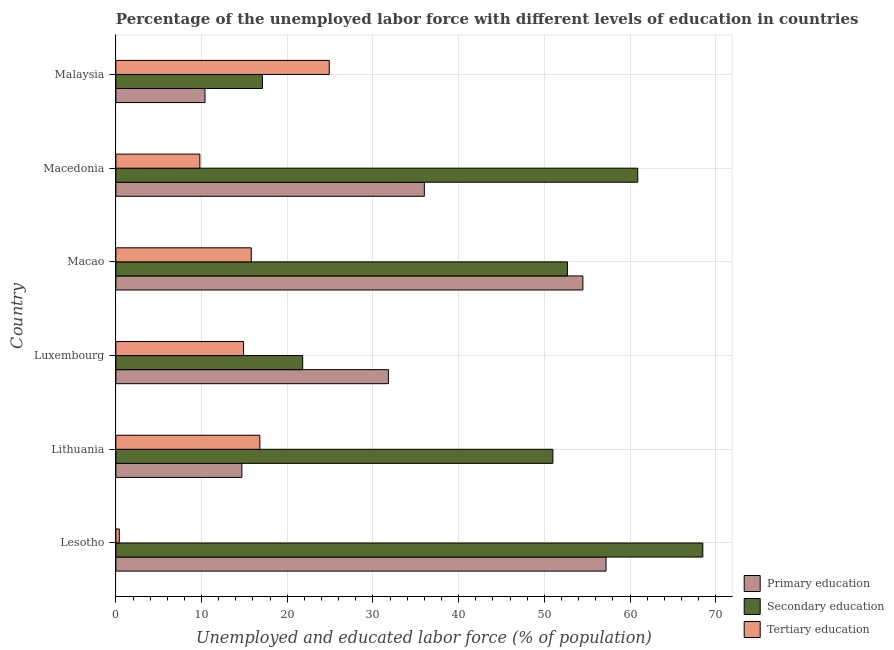How many groups of bars are there?
Your answer should be very brief. 6. Are the number of bars per tick equal to the number of legend labels?
Provide a short and direct response. Yes. What is the label of the 1st group of bars from the top?
Provide a succinct answer. Malaysia. In how many cases, is the number of bars for a given country not equal to the number of legend labels?
Your response must be concise. 0. What is the percentage of labor force who received primary education in Lithuania?
Offer a very short reply. 14.7. Across all countries, what is the maximum percentage of labor force who received primary education?
Give a very brief answer. 57.2. Across all countries, what is the minimum percentage of labor force who received secondary education?
Provide a succinct answer. 17.1. In which country was the percentage of labor force who received secondary education maximum?
Make the answer very short. Lesotho. In which country was the percentage of labor force who received tertiary education minimum?
Keep it short and to the point. Lesotho. What is the total percentage of labor force who received tertiary education in the graph?
Offer a terse response. 82.6. What is the difference between the percentage of labor force who received tertiary education in Macao and that in Macedonia?
Ensure brevity in your answer.  6. What is the difference between the percentage of labor force who received tertiary education in Malaysia and the percentage of labor force who received secondary education in Luxembourg?
Offer a terse response. 3.1. What is the average percentage of labor force who received tertiary education per country?
Your answer should be compact. 13.77. What is the difference between the percentage of labor force who received primary education and percentage of labor force who received tertiary education in Macao?
Make the answer very short. 38.7. In how many countries, is the percentage of labor force who received tertiary education greater than 16 %?
Ensure brevity in your answer.  2. What is the ratio of the percentage of labor force who received primary education in Lithuania to that in Macedonia?
Make the answer very short. 0.41. Is the percentage of labor force who received tertiary education in Lithuania less than that in Macao?
Your response must be concise. No. Is the difference between the percentage of labor force who received secondary education in Lesotho and Macao greater than the difference between the percentage of labor force who received primary education in Lesotho and Macao?
Offer a terse response. Yes. What is the difference between the highest and the second highest percentage of labor force who received primary education?
Ensure brevity in your answer.  2.7. What is the difference between the highest and the lowest percentage of labor force who received secondary education?
Offer a very short reply. 51.4. In how many countries, is the percentage of labor force who received secondary education greater than the average percentage of labor force who received secondary education taken over all countries?
Make the answer very short. 4. Is the sum of the percentage of labor force who received tertiary education in Lithuania and Luxembourg greater than the maximum percentage of labor force who received primary education across all countries?
Your response must be concise. No. What does the 2nd bar from the bottom in Lesotho represents?
Provide a succinct answer. Secondary education. Are the values on the major ticks of X-axis written in scientific E-notation?
Your answer should be very brief. No. Does the graph contain any zero values?
Provide a short and direct response. No. What is the title of the graph?
Provide a succinct answer. Percentage of the unemployed labor force with different levels of education in countries. What is the label or title of the X-axis?
Give a very brief answer. Unemployed and educated labor force (% of population). What is the Unemployed and educated labor force (% of population) of Primary education in Lesotho?
Make the answer very short. 57.2. What is the Unemployed and educated labor force (% of population) of Secondary education in Lesotho?
Provide a short and direct response. 68.5. What is the Unemployed and educated labor force (% of population) of Tertiary education in Lesotho?
Offer a very short reply. 0.4. What is the Unemployed and educated labor force (% of population) in Primary education in Lithuania?
Make the answer very short. 14.7. What is the Unemployed and educated labor force (% of population) of Tertiary education in Lithuania?
Keep it short and to the point. 16.8. What is the Unemployed and educated labor force (% of population) in Primary education in Luxembourg?
Offer a terse response. 31.8. What is the Unemployed and educated labor force (% of population) of Secondary education in Luxembourg?
Your response must be concise. 21.8. What is the Unemployed and educated labor force (% of population) in Tertiary education in Luxembourg?
Offer a very short reply. 14.9. What is the Unemployed and educated labor force (% of population) of Primary education in Macao?
Keep it short and to the point. 54.5. What is the Unemployed and educated labor force (% of population) of Secondary education in Macao?
Ensure brevity in your answer.  52.7. What is the Unemployed and educated labor force (% of population) of Tertiary education in Macao?
Offer a very short reply. 15.8. What is the Unemployed and educated labor force (% of population) of Primary education in Macedonia?
Offer a very short reply. 36. What is the Unemployed and educated labor force (% of population) in Secondary education in Macedonia?
Your answer should be very brief. 60.9. What is the Unemployed and educated labor force (% of population) in Tertiary education in Macedonia?
Ensure brevity in your answer.  9.8. What is the Unemployed and educated labor force (% of population) of Primary education in Malaysia?
Your response must be concise. 10.4. What is the Unemployed and educated labor force (% of population) in Secondary education in Malaysia?
Offer a very short reply. 17.1. What is the Unemployed and educated labor force (% of population) in Tertiary education in Malaysia?
Offer a very short reply. 24.9. Across all countries, what is the maximum Unemployed and educated labor force (% of population) in Primary education?
Offer a very short reply. 57.2. Across all countries, what is the maximum Unemployed and educated labor force (% of population) of Secondary education?
Your response must be concise. 68.5. Across all countries, what is the maximum Unemployed and educated labor force (% of population) in Tertiary education?
Keep it short and to the point. 24.9. Across all countries, what is the minimum Unemployed and educated labor force (% of population) of Primary education?
Provide a succinct answer. 10.4. Across all countries, what is the minimum Unemployed and educated labor force (% of population) in Secondary education?
Keep it short and to the point. 17.1. Across all countries, what is the minimum Unemployed and educated labor force (% of population) in Tertiary education?
Make the answer very short. 0.4. What is the total Unemployed and educated labor force (% of population) of Primary education in the graph?
Make the answer very short. 204.6. What is the total Unemployed and educated labor force (% of population) of Secondary education in the graph?
Provide a short and direct response. 272. What is the total Unemployed and educated labor force (% of population) of Tertiary education in the graph?
Your response must be concise. 82.6. What is the difference between the Unemployed and educated labor force (% of population) in Primary education in Lesotho and that in Lithuania?
Your response must be concise. 42.5. What is the difference between the Unemployed and educated labor force (% of population) in Tertiary education in Lesotho and that in Lithuania?
Keep it short and to the point. -16.4. What is the difference between the Unemployed and educated labor force (% of population) in Primary education in Lesotho and that in Luxembourg?
Give a very brief answer. 25.4. What is the difference between the Unemployed and educated labor force (% of population) of Secondary education in Lesotho and that in Luxembourg?
Provide a succinct answer. 46.7. What is the difference between the Unemployed and educated labor force (% of population) of Tertiary education in Lesotho and that in Luxembourg?
Give a very brief answer. -14.5. What is the difference between the Unemployed and educated labor force (% of population) in Primary education in Lesotho and that in Macao?
Keep it short and to the point. 2.7. What is the difference between the Unemployed and educated labor force (% of population) in Tertiary education in Lesotho and that in Macao?
Make the answer very short. -15.4. What is the difference between the Unemployed and educated labor force (% of population) in Primary education in Lesotho and that in Macedonia?
Offer a terse response. 21.2. What is the difference between the Unemployed and educated labor force (% of population) of Secondary education in Lesotho and that in Macedonia?
Ensure brevity in your answer.  7.6. What is the difference between the Unemployed and educated labor force (% of population) of Primary education in Lesotho and that in Malaysia?
Ensure brevity in your answer.  46.8. What is the difference between the Unemployed and educated labor force (% of population) of Secondary education in Lesotho and that in Malaysia?
Keep it short and to the point. 51.4. What is the difference between the Unemployed and educated labor force (% of population) of Tertiary education in Lesotho and that in Malaysia?
Make the answer very short. -24.5. What is the difference between the Unemployed and educated labor force (% of population) of Primary education in Lithuania and that in Luxembourg?
Ensure brevity in your answer.  -17.1. What is the difference between the Unemployed and educated labor force (% of population) in Secondary education in Lithuania and that in Luxembourg?
Provide a succinct answer. 29.2. What is the difference between the Unemployed and educated labor force (% of population) in Tertiary education in Lithuania and that in Luxembourg?
Your response must be concise. 1.9. What is the difference between the Unemployed and educated labor force (% of population) in Primary education in Lithuania and that in Macao?
Make the answer very short. -39.8. What is the difference between the Unemployed and educated labor force (% of population) of Primary education in Lithuania and that in Macedonia?
Offer a very short reply. -21.3. What is the difference between the Unemployed and educated labor force (% of population) in Secondary education in Lithuania and that in Macedonia?
Make the answer very short. -9.9. What is the difference between the Unemployed and educated labor force (% of population) of Tertiary education in Lithuania and that in Macedonia?
Provide a short and direct response. 7. What is the difference between the Unemployed and educated labor force (% of population) in Secondary education in Lithuania and that in Malaysia?
Provide a short and direct response. 33.9. What is the difference between the Unemployed and educated labor force (% of population) of Tertiary education in Lithuania and that in Malaysia?
Provide a short and direct response. -8.1. What is the difference between the Unemployed and educated labor force (% of population) of Primary education in Luxembourg and that in Macao?
Provide a succinct answer. -22.7. What is the difference between the Unemployed and educated labor force (% of population) of Secondary education in Luxembourg and that in Macao?
Give a very brief answer. -30.9. What is the difference between the Unemployed and educated labor force (% of population) in Primary education in Luxembourg and that in Macedonia?
Ensure brevity in your answer.  -4.2. What is the difference between the Unemployed and educated labor force (% of population) of Secondary education in Luxembourg and that in Macedonia?
Your response must be concise. -39.1. What is the difference between the Unemployed and educated labor force (% of population) in Tertiary education in Luxembourg and that in Macedonia?
Provide a succinct answer. 5.1. What is the difference between the Unemployed and educated labor force (% of population) of Primary education in Luxembourg and that in Malaysia?
Your answer should be compact. 21.4. What is the difference between the Unemployed and educated labor force (% of population) in Primary education in Macao and that in Malaysia?
Offer a terse response. 44.1. What is the difference between the Unemployed and educated labor force (% of population) of Secondary education in Macao and that in Malaysia?
Offer a terse response. 35.6. What is the difference between the Unemployed and educated labor force (% of population) of Tertiary education in Macao and that in Malaysia?
Your response must be concise. -9.1. What is the difference between the Unemployed and educated labor force (% of population) of Primary education in Macedonia and that in Malaysia?
Provide a short and direct response. 25.6. What is the difference between the Unemployed and educated labor force (% of population) in Secondary education in Macedonia and that in Malaysia?
Ensure brevity in your answer.  43.8. What is the difference between the Unemployed and educated labor force (% of population) of Tertiary education in Macedonia and that in Malaysia?
Make the answer very short. -15.1. What is the difference between the Unemployed and educated labor force (% of population) in Primary education in Lesotho and the Unemployed and educated labor force (% of population) in Tertiary education in Lithuania?
Keep it short and to the point. 40.4. What is the difference between the Unemployed and educated labor force (% of population) in Secondary education in Lesotho and the Unemployed and educated labor force (% of population) in Tertiary education in Lithuania?
Keep it short and to the point. 51.7. What is the difference between the Unemployed and educated labor force (% of population) in Primary education in Lesotho and the Unemployed and educated labor force (% of population) in Secondary education in Luxembourg?
Your answer should be very brief. 35.4. What is the difference between the Unemployed and educated labor force (% of population) of Primary education in Lesotho and the Unemployed and educated labor force (% of population) of Tertiary education in Luxembourg?
Your response must be concise. 42.3. What is the difference between the Unemployed and educated labor force (% of population) in Secondary education in Lesotho and the Unemployed and educated labor force (% of population) in Tertiary education in Luxembourg?
Keep it short and to the point. 53.6. What is the difference between the Unemployed and educated labor force (% of population) of Primary education in Lesotho and the Unemployed and educated labor force (% of population) of Secondary education in Macao?
Make the answer very short. 4.5. What is the difference between the Unemployed and educated labor force (% of population) of Primary education in Lesotho and the Unemployed and educated labor force (% of population) of Tertiary education in Macao?
Your answer should be very brief. 41.4. What is the difference between the Unemployed and educated labor force (% of population) of Secondary education in Lesotho and the Unemployed and educated labor force (% of population) of Tertiary education in Macao?
Offer a very short reply. 52.7. What is the difference between the Unemployed and educated labor force (% of population) in Primary education in Lesotho and the Unemployed and educated labor force (% of population) in Tertiary education in Macedonia?
Your answer should be very brief. 47.4. What is the difference between the Unemployed and educated labor force (% of population) of Secondary education in Lesotho and the Unemployed and educated labor force (% of population) of Tertiary education in Macedonia?
Your answer should be compact. 58.7. What is the difference between the Unemployed and educated labor force (% of population) in Primary education in Lesotho and the Unemployed and educated labor force (% of population) in Secondary education in Malaysia?
Your answer should be compact. 40.1. What is the difference between the Unemployed and educated labor force (% of population) of Primary education in Lesotho and the Unemployed and educated labor force (% of population) of Tertiary education in Malaysia?
Provide a succinct answer. 32.3. What is the difference between the Unemployed and educated labor force (% of population) in Secondary education in Lesotho and the Unemployed and educated labor force (% of population) in Tertiary education in Malaysia?
Offer a terse response. 43.6. What is the difference between the Unemployed and educated labor force (% of population) of Primary education in Lithuania and the Unemployed and educated labor force (% of population) of Secondary education in Luxembourg?
Give a very brief answer. -7.1. What is the difference between the Unemployed and educated labor force (% of population) of Secondary education in Lithuania and the Unemployed and educated labor force (% of population) of Tertiary education in Luxembourg?
Give a very brief answer. 36.1. What is the difference between the Unemployed and educated labor force (% of population) in Primary education in Lithuania and the Unemployed and educated labor force (% of population) in Secondary education in Macao?
Provide a short and direct response. -38. What is the difference between the Unemployed and educated labor force (% of population) of Secondary education in Lithuania and the Unemployed and educated labor force (% of population) of Tertiary education in Macao?
Offer a very short reply. 35.2. What is the difference between the Unemployed and educated labor force (% of population) in Primary education in Lithuania and the Unemployed and educated labor force (% of population) in Secondary education in Macedonia?
Your answer should be compact. -46.2. What is the difference between the Unemployed and educated labor force (% of population) of Secondary education in Lithuania and the Unemployed and educated labor force (% of population) of Tertiary education in Macedonia?
Ensure brevity in your answer.  41.2. What is the difference between the Unemployed and educated labor force (% of population) of Primary education in Lithuania and the Unemployed and educated labor force (% of population) of Tertiary education in Malaysia?
Give a very brief answer. -10.2. What is the difference between the Unemployed and educated labor force (% of population) of Secondary education in Lithuania and the Unemployed and educated labor force (% of population) of Tertiary education in Malaysia?
Keep it short and to the point. 26.1. What is the difference between the Unemployed and educated labor force (% of population) of Primary education in Luxembourg and the Unemployed and educated labor force (% of population) of Secondary education in Macao?
Provide a succinct answer. -20.9. What is the difference between the Unemployed and educated labor force (% of population) of Primary education in Luxembourg and the Unemployed and educated labor force (% of population) of Tertiary education in Macao?
Provide a short and direct response. 16. What is the difference between the Unemployed and educated labor force (% of population) in Primary education in Luxembourg and the Unemployed and educated labor force (% of population) in Secondary education in Macedonia?
Your response must be concise. -29.1. What is the difference between the Unemployed and educated labor force (% of population) in Secondary education in Luxembourg and the Unemployed and educated labor force (% of population) in Tertiary education in Macedonia?
Ensure brevity in your answer.  12. What is the difference between the Unemployed and educated labor force (% of population) in Secondary education in Luxembourg and the Unemployed and educated labor force (% of population) in Tertiary education in Malaysia?
Your answer should be compact. -3.1. What is the difference between the Unemployed and educated labor force (% of population) in Primary education in Macao and the Unemployed and educated labor force (% of population) in Secondary education in Macedonia?
Offer a very short reply. -6.4. What is the difference between the Unemployed and educated labor force (% of population) in Primary education in Macao and the Unemployed and educated labor force (% of population) in Tertiary education in Macedonia?
Offer a very short reply. 44.7. What is the difference between the Unemployed and educated labor force (% of population) in Secondary education in Macao and the Unemployed and educated labor force (% of population) in Tertiary education in Macedonia?
Make the answer very short. 42.9. What is the difference between the Unemployed and educated labor force (% of population) of Primary education in Macao and the Unemployed and educated labor force (% of population) of Secondary education in Malaysia?
Your answer should be very brief. 37.4. What is the difference between the Unemployed and educated labor force (% of population) in Primary education in Macao and the Unemployed and educated labor force (% of population) in Tertiary education in Malaysia?
Keep it short and to the point. 29.6. What is the difference between the Unemployed and educated labor force (% of population) of Secondary education in Macao and the Unemployed and educated labor force (% of population) of Tertiary education in Malaysia?
Provide a short and direct response. 27.8. What is the difference between the Unemployed and educated labor force (% of population) in Primary education in Macedonia and the Unemployed and educated labor force (% of population) in Secondary education in Malaysia?
Offer a terse response. 18.9. What is the difference between the Unemployed and educated labor force (% of population) of Secondary education in Macedonia and the Unemployed and educated labor force (% of population) of Tertiary education in Malaysia?
Give a very brief answer. 36. What is the average Unemployed and educated labor force (% of population) in Primary education per country?
Provide a short and direct response. 34.1. What is the average Unemployed and educated labor force (% of population) of Secondary education per country?
Your answer should be very brief. 45.33. What is the average Unemployed and educated labor force (% of population) of Tertiary education per country?
Make the answer very short. 13.77. What is the difference between the Unemployed and educated labor force (% of population) in Primary education and Unemployed and educated labor force (% of population) in Secondary education in Lesotho?
Keep it short and to the point. -11.3. What is the difference between the Unemployed and educated labor force (% of population) in Primary education and Unemployed and educated labor force (% of population) in Tertiary education in Lesotho?
Provide a short and direct response. 56.8. What is the difference between the Unemployed and educated labor force (% of population) in Secondary education and Unemployed and educated labor force (% of population) in Tertiary education in Lesotho?
Offer a terse response. 68.1. What is the difference between the Unemployed and educated labor force (% of population) of Primary education and Unemployed and educated labor force (% of population) of Secondary education in Lithuania?
Your response must be concise. -36.3. What is the difference between the Unemployed and educated labor force (% of population) in Secondary education and Unemployed and educated labor force (% of population) in Tertiary education in Lithuania?
Provide a succinct answer. 34.2. What is the difference between the Unemployed and educated labor force (% of population) of Primary education and Unemployed and educated labor force (% of population) of Tertiary education in Luxembourg?
Your answer should be very brief. 16.9. What is the difference between the Unemployed and educated labor force (% of population) of Secondary education and Unemployed and educated labor force (% of population) of Tertiary education in Luxembourg?
Keep it short and to the point. 6.9. What is the difference between the Unemployed and educated labor force (% of population) of Primary education and Unemployed and educated labor force (% of population) of Secondary education in Macao?
Give a very brief answer. 1.8. What is the difference between the Unemployed and educated labor force (% of population) of Primary education and Unemployed and educated labor force (% of population) of Tertiary education in Macao?
Keep it short and to the point. 38.7. What is the difference between the Unemployed and educated labor force (% of population) of Secondary education and Unemployed and educated labor force (% of population) of Tertiary education in Macao?
Offer a very short reply. 36.9. What is the difference between the Unemployed and educated labor force (% of population) of Primary education and Unemployed and educated labor force (% of population) of Secondary education in Macedonia?
Your answer should be very brief. -24.9. What is the difference between the Unemployed and educated labor force (% of population) in Primary education and Unemployed and educated labor force (% of population) in Tertiary education in Macedonia?
Offer a terse response. 26.2. What is the difference between the Unemployed and educated labor force (% of population) of Secondary education and Unemployed and educated labor force (% of population) of Tertiary education in Macedonia?
Keep it short and to the point. 51.1. What is the ratio of the Unemployed and educated labor force (% of population) in Primary education in Lesotho to that in Lithuania?
Offer a terse response. 3.89. What is the ratio of the Unemployed and educated labor force (% of population) in Secondary education in Lesotho to that in Lithuania?
Offer a very short reply. 1.34. What is the ratio of the Unemployed and educated labor force (% of population) in Tertiary education in Lesotho to that in Lithuania?
Offer a terse response. 0.02. What is the ratio of the Unemployed and educated labor force (% of population) in Primary education in Lesotho to that in Luxembourg?
Offer a very short reply. 1.8. What is the ratio of the Unemployed and educated labor force (% of population) in Secondary education in Lesotho to that in Luxembourg?
Provide a short and direct response. 3.14. What is the ratio of the Unemployed and educated labor force (% of population) of Tertiary education in Lesotho to that in Luxembourg?
Your answer should be compact. 0.03. What is the ratio of the Unemployed and educated labor force (% of population) of Primary education in Lesotho to that in Macao?
Make the answer very short. 1.05. What is the ratio of the Unemployed and educated labor force (% of population) in Secondary education in Lesotho to that in Macao?
Provide a short and direct response. 1.3. What is the ratio of the Unemployed and educated labor force (% of population) in Tertiary education in Lesotho to that in Macao?
Provide a short and direct response. 0.03. What is the ratio of the Unemployed and educated labor force (% of population) of Primary education in Lesotho to that in Macedonia?
Ensure brevity in your answer.  1.59. What is the ratio of the Unemployed and educated labor force (% of population) of Secondary education in Lesotho to that in Macedonia?
Your answer should be very brief. 1.12. What is the ratio of the Unemployed and educated labor force (% of population) in Tertiary education in Lesotho to that in Macedonia?
Ensure brevity in your answer.  0.04. What is the ratio of the Unemployed and educated labor force (% of population) of Primary education in Lesotho to that in Malaysia?
Offer a terse response. 5.5. What is the ratio of the Unemployed and educated labor force (% of population) in Secondary education in Lesotho to that in Malaysia?
Ensure brevity in your answer.  4.01. What is the ratio of the Unemployed and educated labor force (% of population) in Tertiary education in Lesotho to that in Malaysia?
Give a very brief answer. 0.02. What is the ratio of the Unemployed and educated labor force (% of population) in Primary education in Lithuania to that in Luxembourg?
Ensure brevity in your answer.  0.46. What is the ratio of the Unemployed and educated labor force (% of population) of Secondary education in Lithuania to that in Luxembourg?
Your response must be concise. 2.34. What is the ratio of the Unemployed and educated labor force (% of population) in Tertiary education in Lithuania to that in Luxembourg?
Ensure brevity in your answer.  1.13. What is the ratio of the Unemployed and educated labor force (% of population) in Primary education in Lithuania to that in Macao?
Offer a terse response. 0.27. What is the ratio of the Unemployed and educated labor force (% of population) of Tertiary education in Lithuania to that in Macao?
Your answer should be compact. 1.06. What is the ratio of the Unemployed and educated labor force (% of population) of Primary education in Lithuania to that in Macedonia?
Provide a short and direct response. 0.41. What is the ratio of the Unemployed and educated labor force (% of population) of Secondary education in Lithuania to that in Macedonia?
Make the answer very short. 0.84. What is the ratio of the Unemployed and educated labor force (% of population) of Tertiary education in Lithuania to that in Macedonia?
Give a very brief answer. 1.71. What is the ratio of the Unemployed and educated labor force (% of population) of Primary education in Lithuania to that in Malaysia?
Ensure brevity in your answer.  1.41. What is the ratio of the Unemployed and educated labor force (% of population) in Secondary education in Lithuania to that in Malaysia?
Ensure brevity in your answer.  2.98. What is the ratio of the Unemployed and educated labor force (% of population) of Tertiary education in Lithuania to that in Malaysia?
Ensure brevity in your answer.  0.67. What is the ratio of the Unemployed and educated labor force (% of population) of Primary education in Luxembourg to that in Macao?
Your answer should be very brief. 0.58. What is the ratio of the Unemployed and educated labor force (% of population) of Secondary education in Luxembourg to that in Macao?
Ensure brevity in your answer.  0.41. What is the ratio of the Unemployed and educated labor force (% of population) of Tertiary education in Luxembourg to that in Macao?
Give a very brief answer. 0.94. What is the ratio of the Unemployed and educated labor force (% of population) of Primary education in Luxembourg to that in Macedonia?
Ensure brevity in your answer.  0.88. What is the ratio of the Unemployed and educated labor force (% of population) of Secondary education in Luxembourg to that in Macedonia?
Provide a succinct answer. 0.36. What is the ratio of the Unemployed and educated labor force (% of population) of Tertiary education in Luxembourg to that in Macedonia?
Offer a very short reply. 1.52. What is the ratio of the Unemployed and educated labor force (% of population) of Primary education in Luxembourg to that in Malaysia?
Ensure brevity in your answer.  3.06. What is the ratio of the Unemployed and educated labor force (% of population) of Secondary education in Luxembourg to that in Malaysia?
Give a very brief answer. 1.27. What is the ratio of the Unemployed and educated labor force (% of population) in Tertiary education in Luxembourg to that in Malaysia?
Offer a terse response. 0.6. What is the ratio of the Unemployed and educated labor force (% of population) of Primary education in Macao to that in Macedonia?
Your answer should be very brief. 1.51. What is the ratio of the Unemployed and educated labor force (% of population) of Secondary education in Macao to that in Macedonia?
Keep it short and to the point. 0.87. What is the ratio of the Unemployed and educated labor force (% of population) in Tertiary education in Macao to that in Macedonia?
Your response must be concise. 1.61. What is the ratio of the Unemployed and educated labor force (% of population) of Primary education in Macao to that in Malaysia?
Provide a succinct answer. 5.24. What is the ratio of the Unemployed and educated labor force (% of population) of Secondary education in Macao to that in Malaysia?
Ensure brevity in your answer.  3.08. What is the ratio of the Unemployed and educated labor force (% of population) of Tertiary education in Macao to that in Malaysia?
Provide a succinct answer. 0.63. What is the ratio of the Unemployed and educated labor force (% of population) in Primary education in Macedonia to that in Malaysia?
Give a very brief answer. 3.46. What is the ratio of the Unemployed and educated labor force (% of population) of Secondary education in Macedonia to that in Malaysia?
Keep it short and to the point. 3.56. What is the ratio of the Unemployed and educated labor force (% of population) in Tertiary education in Macedonia to that in Malaysia?
Provide a succinct answer. 0.39. What is the difference between the highest and the second highest Unemployed and educated labor force (% of population) of Primary education?
Offer a very short reply. 2.7. What is the difference between the highest and the second highest Unemployed and educated labor force (% of population) in Secondary education?
Your answer should be compact. 7.6. What is the difference between the highest and the second highest Unemployed and educated labor force (% of population) in Tertiary education?
Give a very brief answer. 8.1. What is the difference between the highest and the lowest Unemployed and educated labor force (% of population) in Primary education?
Offer a very short reply. 46.8. What is the difference between the highest and the lowest Unemployed and educated labor force (% of population) of Secondary education?
Your response must be concise. 51.4. What is the difference between the highest and the lowest Unemployed and educated labor force (% of population) of Tertiary education?
Your answer should be very brief. 24.5. 